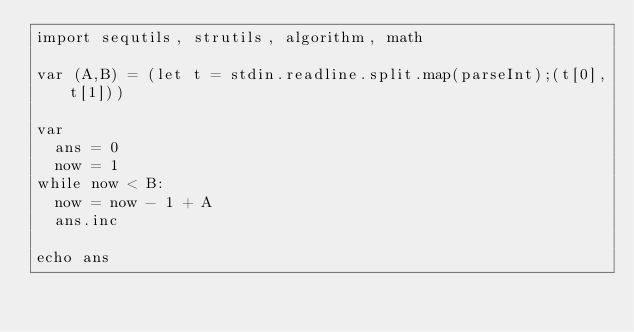<code> <loc_0><loc_0><loc_500><loc_500><_Nim_>import sequtils, strutils, algorithm, math

var (A,B) = (let t = stdin.readline.split.map(parseInt);(t[0],t[1]))

var
  ans = 0
  now = 1
while now < B:
  now = now - 1 + A
  ans.inc

echo ans</code> 